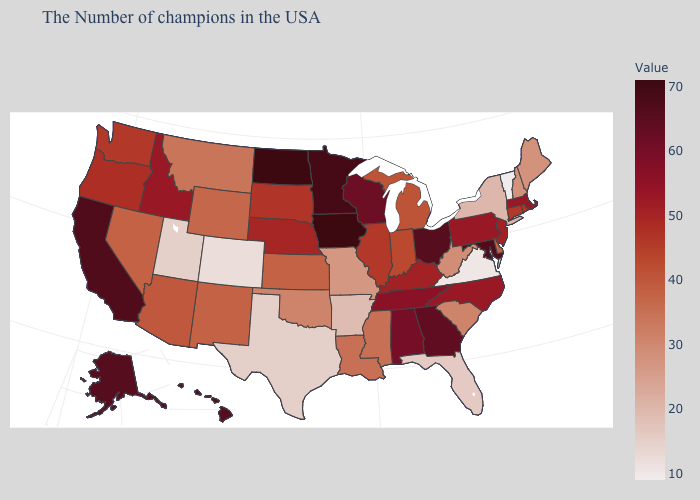Which states have the lowest value in the Northeast?
Be succinct. Vermont. Which states have the lowest value in the MidWest?
Short answer required. Missouri. Does Colorado have the highest value in the USA?
Keep it brief. No. Among the states that border New York , which have the lowest value?
Write a very short answer. Vermont. Among the states that border Texas , does Arkansas have the lowest value?
Give a very brief answer. Yes. Which states hav the highest value in the Northeast?
Concise answer only. Massachusetts, Pennsylvania. Which states have the lowest value in the MidWest?
Be succinct. Missouri. 